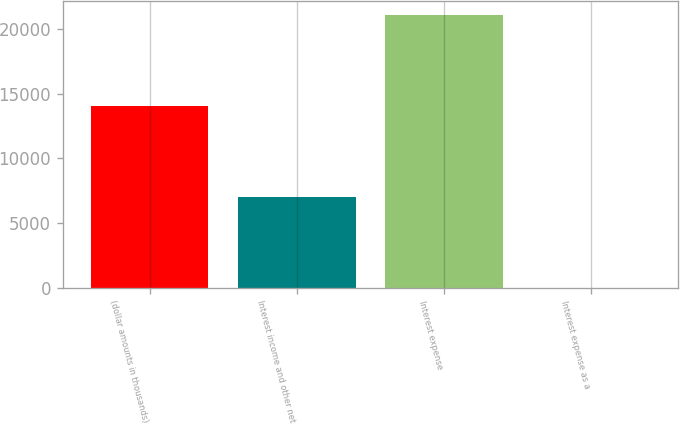Convert chart. <chart><loc_0><loc_0><loc_500><loc_500><bar_chart><fcel>(dollar amounts in thousands)<fcel>Interest income and other net<fcel>Interest expense<fcel>Interest expense as a<nl><fcel>14050.7<fcel>7026.79<fcel>21074.6<fcel>2.88<nl></chart> 